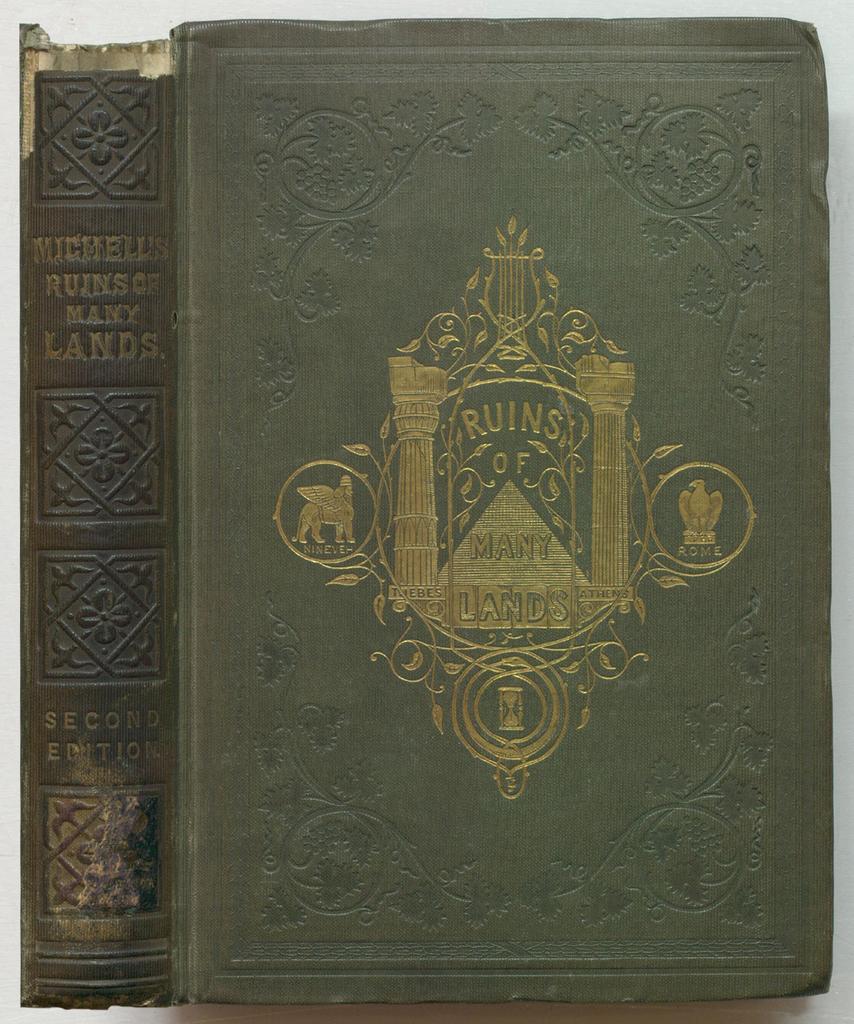Which edition is this?
Give a very brief answer. Second. What is this book called?
Ensure brevity in your answer.  Ruins of many lands. 